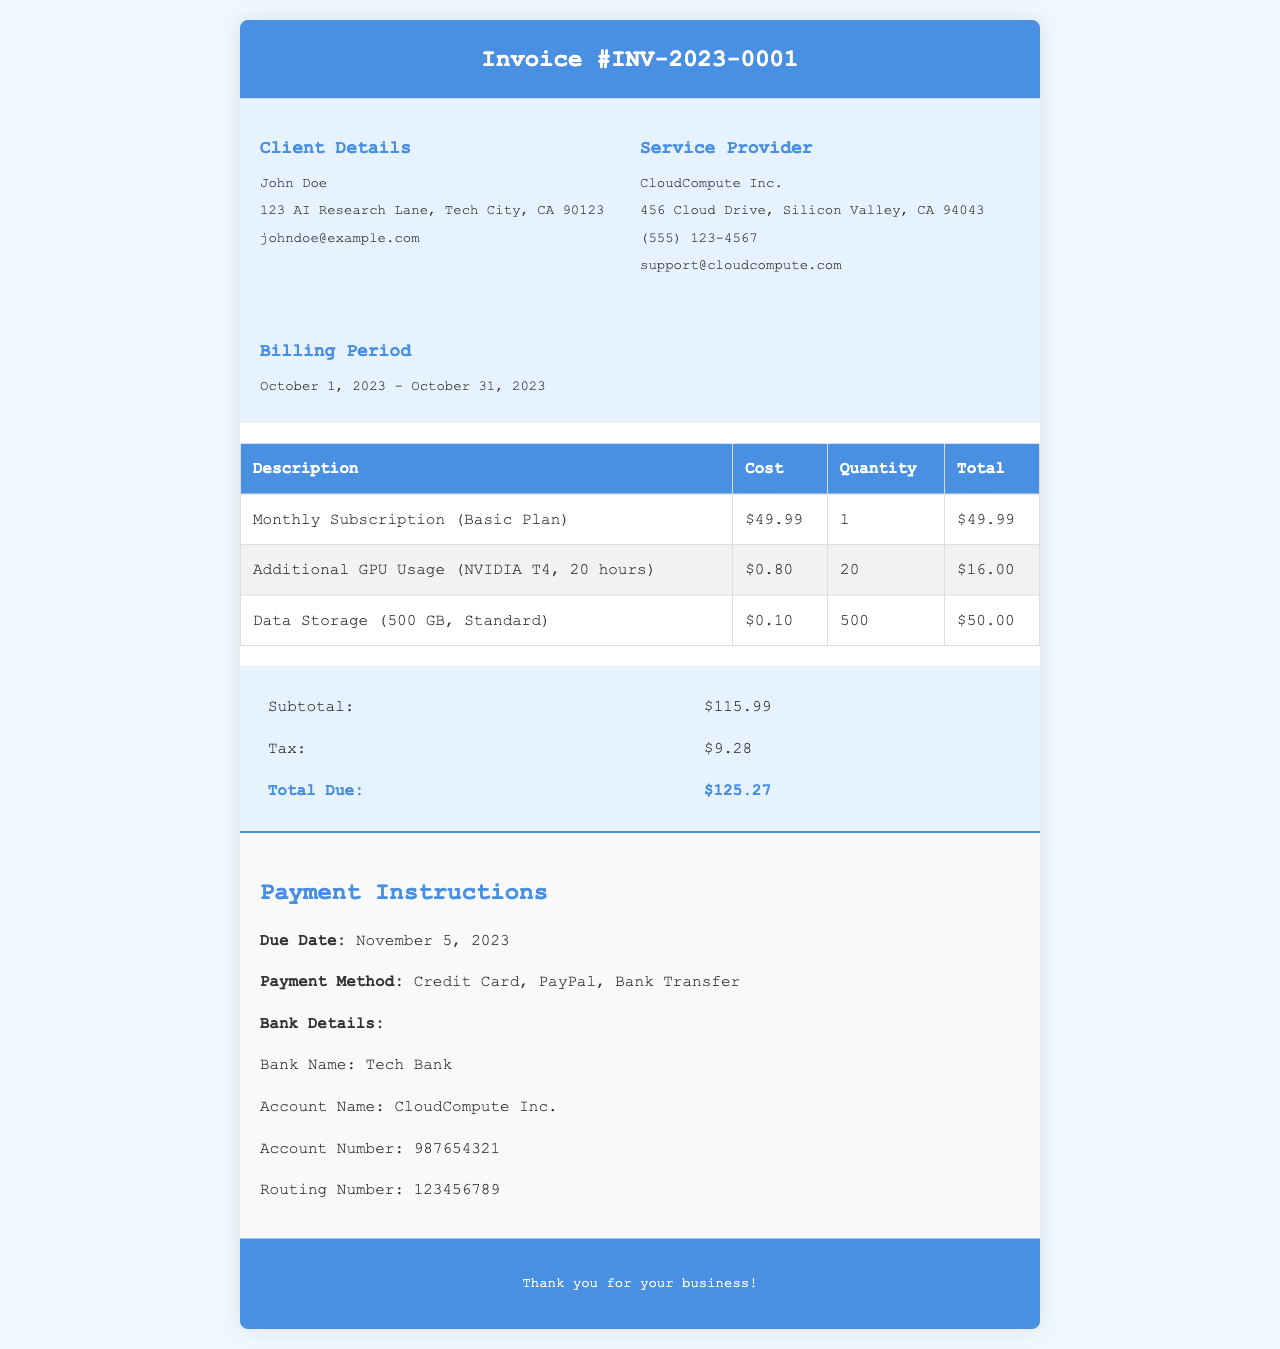What is the invoice number? The invoice number is clearly stated in the header of the document as Invoice #INV-2023-0001.
Answer: Invoice #INV-2023-0001 Who is the client? The client's name is provided in the information section, which is John Doe.
Answer: John Doe What is the total due? The total amount due at the end of the summary section is explicitly listed as $125.27.
Answer: $125.27 How much is charged for data storage? The table outlines the data storage fee, which is $0.10 per GB.
Answer: $0.10 What is the billing period? The billing period is specified in the document as October 1, 2023 - October 31, 2023.
Answer: October 1, 2023 - October 31, 2023 How many hours of additional GPU usage were billed? The document states the additional GPU usage was for 20 hours under a specific entry in the services table.
Answer: 20 What is the subtotal before tax? The subtotal amount listed in the summary section before tax is $115.99.
Answer: $115.99 When is the payment due? The document states that the payment is due on November 5, 2023, in the payment instructions section.
Answer: November 5, 2023 What payment methods are accepted? The payment instructions outline the accepted methods: Credit Card, PayPal, Bank Transfer.
Answer: Credit Card, PayPal, Bank Transfer 